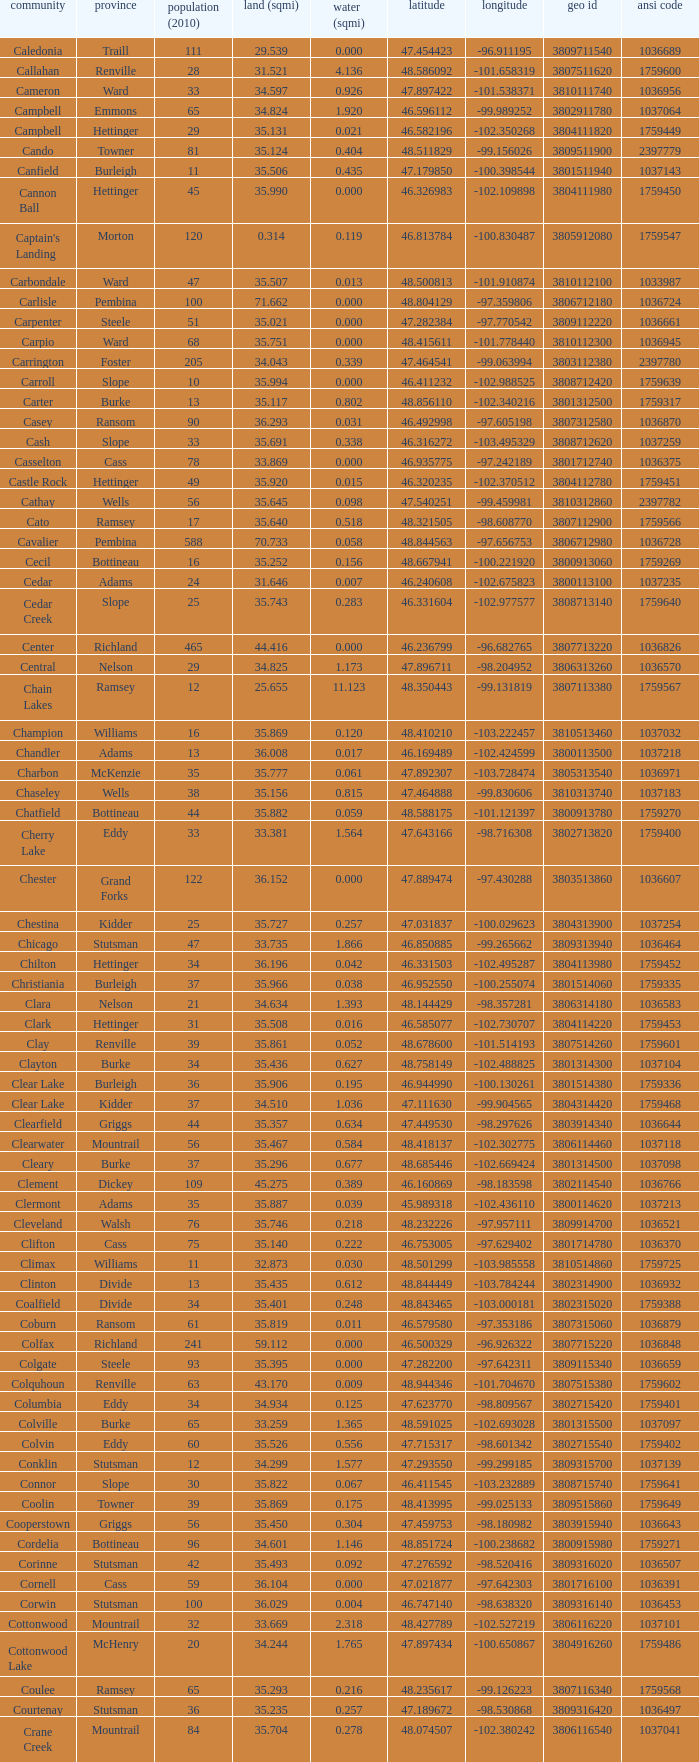Can you identify the township with a geo id of 3807116660? Creel. Could you parse the entire table? {'header': ['community', 'province', 'population (2010)', 'land (sqmi)', 'water (sqmi)', 'latitude', 'longitude', 'geo id', 'ansi code'], 'rows': [['Caledonia', 'Traill', '111', '29.539', '0.000', '47.454423', '-96.911195', '3809711540', '1036689'], ['Callahan', 'Renville', '28', '31.521', '4.136', '48.586092', '-101.658319', '3807511620', '1759600'], ['Cameron', 'Ward', '33', '34.597', '0.926', '47.897422', '-101.538371', '3810111740', '1036956'], ['Campbell', 'Emmons', '65', '34.824', '1.920', '46.596112', '-99.989252', '3802911780', '1037064'], ['Campbell', 'Hettinger', '29', '35.131', '0.021', '46.582196', '-102.350268', '3804111820', '1759449'], ['Cando', 'Towner', '81', '35.124', '0.404', '48.511829', '-99.156026', '3809511900', '2397779'], ['Canfield', 'Burleigh', '11', '35.506', '0.435', '47.179850', '-100.398544', '3801511940', '1037143'], ['Cannon Ball', 'Hettinger', '45', '35.990', '0.000', '46.326983', '-102.109898', '3804111980', '1759450'], ["Captain's Landing", 'Morton', '120', '0.314', '0.119', '46.813784', '-100.830487', '3805912080', '1759547'], ['Carbondale', 'Ward', '47', '35.507', '0.013', '48.500813', '-101.910874', '3810112100', '1033987'], ['Carlisle', 'Pembina', '100', '71.662', '0.000', '48.804129', '-97.359806', '3806712180', '1036724'], ['Carpenter', 'Steele', '51', '35.021', '0.000', '47.282384', '-97.770542', '3809112220', '1036661'], ['Carpio', 'Ward', '68', '35.751', '0.000', '48.415611', '-101.778440', '3810112300', '1036945'], ['Carrington', 'Foster', '205', '34.043', '0.339', '47.464541', '-99.063994', '3803112380', '2397780'], ['Carroll', 'Slope', '10', '35.994', '0.000', '46.411232', '-102.988525', '3808712420', '1759639'], ['Carter', 'Burke', '13', '35.117', '0.802', '48.856110', '-102.340216', '3801312500', '1759317'], ['Casey', 'Ransom', '90', '36.293', '0.031', '46.492998', '-97.605198', '3807312580', '1036870'], ['Cash', 'Slope', '33', '35.691', '0.338', '46.316272', '-103.495329', '3808712620', '1037259'], ['Casselton', 'Cass', '78', '33.869', '0.000', '46.935775', '-97.242189', '3801712740', '1036375'], ['Castle Rock', 'Hettinger', '49', '35.920', '0.015', '46.320235', '-102.370512', '3804112780', '1759451'], ['Cathay', 'Wells', '56', '35.645', '0.098', '47.540251', '-99.459981', '3810312860', '2397782'], ['Cato', 'Ramsey', '17', '35.640', '0.518', '48.321505', '-98.608770', '3807112900', '1759566'], ['Cavalier', 'Pembina', '588', '70.733', '0.058', '48.844563', '-97.656753', '3806712980', '1036728'], ['Cecil', 'Bottineau', '16', '35.252', '0.156', '48.667941', '-100.221920', '3800913060', '1759269'], ['Cedar', 'Adams', '24', '31.646', '0.007', '46.240608', '-102.675823', '3800113100', '1037235'], ['Cedar Creek', 'Slope', '25', '35.743', '0.283', '46.331604', '-102.977577', '3808713140', '1759640'], ['Center', 'Richland', '465', '44.416', '0.000', '46.236799', '-96.682765', '3807713220', '1036826'], ['Central', 'Nelson', '29', '34.825', '1.173', '47.896711', '-98.204952', '3806313260', '1036570'], ['Chain Lakes', 'Ramsey', '12', '25.655', '11.123', '48.350443', '-99.131819', '3807113380', '1759567'], ['Champion', 'Williams', '16', '35.869', '0.120', '48.410210', '-103.222457', '3810513460', '1037032'], ['Chandler', 'Adams', '13', '36.008', '0.017', '46.169489', '-102.424599', '3800113500', '1037218'], ['Charbon', 'McKenzie', '35', '35.777', '0.061', '47.892307', '-103.728474', '3805313540', '1036971'], ['Chaseley', 'Wells', '38', '35.156', '0.815', '47.464888', '-99.830606', '3810313740', '1037183'], ['Chatfield', 'Bottineau', '44', '35.882', '0.059', '48.588175', '-101.121397', '3800913780', '1759270'], ['Cherry Lake', 'Eddy', '33', '33.381', '1.564', '47.643166', '-98.716308', '3802713820', '1759400'], ['Chester', 'Grand Forks', '122', '36.152', '0.000', '47.889474', '-97.430288', '3803513860', '1036607'], ['Chestina', 'Kidder', '25', '35.727', '0.257', '47.031837', '-100.029623', '3804313900', '1037254'], ['Chicago', 'Stutsman', '47', '33.735', '1.866', '46.850885', '-99.265662', '3809313940', '1036464'], ['Chilton', 'Hettinger', '34', '36.196', '0.042', '46.331503', '-102.495287', '3804113980', '1759452'], ['Christiania', 'Burleigh', '37', '35.966', '0.038', '46.952550', '-100.255074', '3801514060', '1759335'], ['Clara', 'Nelson', '21', '34.634', '1.393', '48.144429', '-98.357281', '3806314180', '1036583'], ['Clark', 'Hettinger', '31', '35.508', '0.016', '46.585077', '-102.730707', '3804114220', '1759453'], ['Clay', 'Renville', '39', '35.861', '0.052', '48.678600', '-101.514193', '3807514260', '1759601'], ['Clayton', 'Burke', '34', '35.436', '0.627', '48.758149', '-102.488825', '3801314300', '1037104'], ['Clear Lake', 'Burleigh', '36', '35.906', '0.195', '46.944990', '-100.130261', '3801514380', '1759336'], ['Clear Lake', 'Kidder', '37', '34.510', '1.036', '47.111630', '-99.904565', '3804314420', '1759468'], ['Clearfield', 'Griggs', '44', '35.357', '0.634', '47.449530', '-98.297626', '3803914340', '1036644'], ['Clearwater', 'Mountrail', '56', '35.467', '0.584', '48.418137', '-102.302775', '3806114460', '1037118'], ['Cleary', 'Burke', '37', '35.296', '0.677', '48.685446', '-102.669424', '3801314500', '1037098'], ['Clement', 'Dickey', '109', '45.275', '0.389', '46.160869', '-98.183598', '3802114540', '1036766'], ['Clermont', 'Adams', '35', '35.887', '0.039', '45.989318', '-102.436110', '3800114620', '1037213'], ['Cleveland', 'Walsh', '76', '35.746', '0.218', '48.232226', '-97.957111', '3809914700', '1036521'], ['Clifton', 'Cass', '75', '35.140', '0.222', '46.753005', '-97.629402', '3801714780', '1036370'], ['Climax', 'Williams', '11', '32.873', '0.030', '48.501299', '-103.985558', '3810514860', '1759725'], ['Clinton', 'Divide', '13', '35.435', '0.612', '48.844449', '-103.784244', '3802314900', '1036932'], ['Coalfield', 'Divide', '34', '35.401', '0.248', '48.843465', '-103.000181', '3802315020', '1759388'], ['Coburn', 'Ransom', '61', '35.819', '0.011', '46.579580', '-97.353186', '3807315060', '1036879'], ['Colfax', 'Richland', '241', '59.112', '0.000', '46.500329', '-96.926322', '3807715220', '1036848'], ['Colgate', 'Steele', '93', '35.395', '0.000', '47.282200', '-97.642311', '3809115340', '1036659'], ['Colquhoun', 'Renville', '63', '43.170', '0.009', '48.944346', '-101.704670', '3807515380', '1759602'], ['Columbia', 'Eddy', '34', '34.934', '0.125', '47.623770', '-98.809567', '3802715420', '1759401'], ['Colville', 'Burke', '65', '33.259', '1.365', '48.591025', '-102.693028', '3801315500', '1037097'], ['Colvin', 'Eddy', '60', '35.526', '0.556', '47.715317', '-98.601342', '3802715540', '1759402'], ['Conklin', 'Stutsman', '12', '34.299', '1.577', '47.293550', '-99.299185', '3809315700', '1037139'], ['Connor', 'Slope', '30', '35.822', '0.067', '46.411545', '-103.232889', '3808715740', '1759641'], ['Coolin', 'Towner', '39', '35.869', '0.175', '48.413995', '-99.025133', '3809515860', '1759649'], ['Cooperstown', 'Griggs', '56', '35.450', '0.304', '47.459753', '-98.180982', '3803915940', '1036643'], ['Cordelia', 'Bottineau', '96', '34.601', '1.146', '48.851724', '-100.238682', '3800915980', '1759271'], ['Corinne', 'Stutsman', '42', '35.493', '0.092', '47.276592', '-98.520416', '3809316020', '1036507'], ['Cornell', 'Cass', '59', '36.104', '0.000', '47.021877', '-97.642303', '3801716100', '1036391'], ['Corwin', 'Stutsman', '100', '36.029', '0.004', '46.747140', '-98.638320', '3809316140', '1036453'], ['Cottonwood', 'Mountrail', '32', '33.669', '2.318', '48.427789', '-102.527219', '3806116220', '1037101'], ['Cottonwood Lake', 'McHenry', '20', '34.244', '1.765', '47.897434', '-100.650867', '3804916260', '1759486'], ['Coulee', 'Ramsey', '65', '35.293', '0.216', '48.235617', '-99.126223', '3807116340', '1759568'], ['Courtenay', 'Stutsman', '36', '35.235', '0.257', '47.189672', '-98.530868', '3809316420', '1036497'], ['Crane Creek', 'Mountrail', '84', '35.704', '0.278', '48.074507', '-102.380242', '3806116540', '1037041'], ['Crawford', 'Slope', '31', '35.892', '0.051', '46.320329', '-103.729934', '3808716620', '1037166'], ['Creel', 'Ramsey', '1305', '14.578', '15.621', '48.075823', '-98.857272', '3807116660', '1759569'], ['Cremerville', 'McLean', '27', '35.739', '0.054', '47.811011', '-102.054883', '3805516700', '1759530'], ['Crocus', 'Towner', '44', '35.047', '0.940', '48.667289', '-99.155787', '3809516820', '1759650'], ['Crofte', 'Burleigh', '199', '36.163', '0.000', '47.026425', '-100.685988', '3801516860', '1037131'], ['Cromwell', 'Burleigh', '35', '36.208', '0.000', '47.026008', '-100.558805', '3801516900', '1037133'], ['Crowfoot', 'Mountrail', '18', '34.701', '1.283', '48.495946', '-102.180433', '3806116980', '1037050'], ['Crown Hill', 'Kidder', '7', '30.799', '1.468', '46.770977', '-100.025924', '3804317020', '1759469'], ['Crystal', 'Pembina', '50', '35.499', '0.000', '48.586423', '-97.732145', '3806717100', '1036718'], ['Crystal Lake', 'Wells', '32', '35.522', '0.424', '47.541346', '-99.974737', '3810317140', '1037152'], ['Crystal Springs', 'Kidder', '32', '35.415', '0.636', '46.848792', '-99.529639', '3804317220', '1759470'], ['Cuba', 'Barnes', '76', '35.709', '0.032', '46.851144', '-97.860271', '3800317300', '1036409'], ['Cusator', 'Stutsman', '26', '34.878', '0.693', '46.746853', '-98.997611', '3809317460', '1036459'], ['Cut Bank', 'Bottineau', '37', '35.898', '0.033', '48.763937', '-101.430571', '3800917540', '1759272']]} 